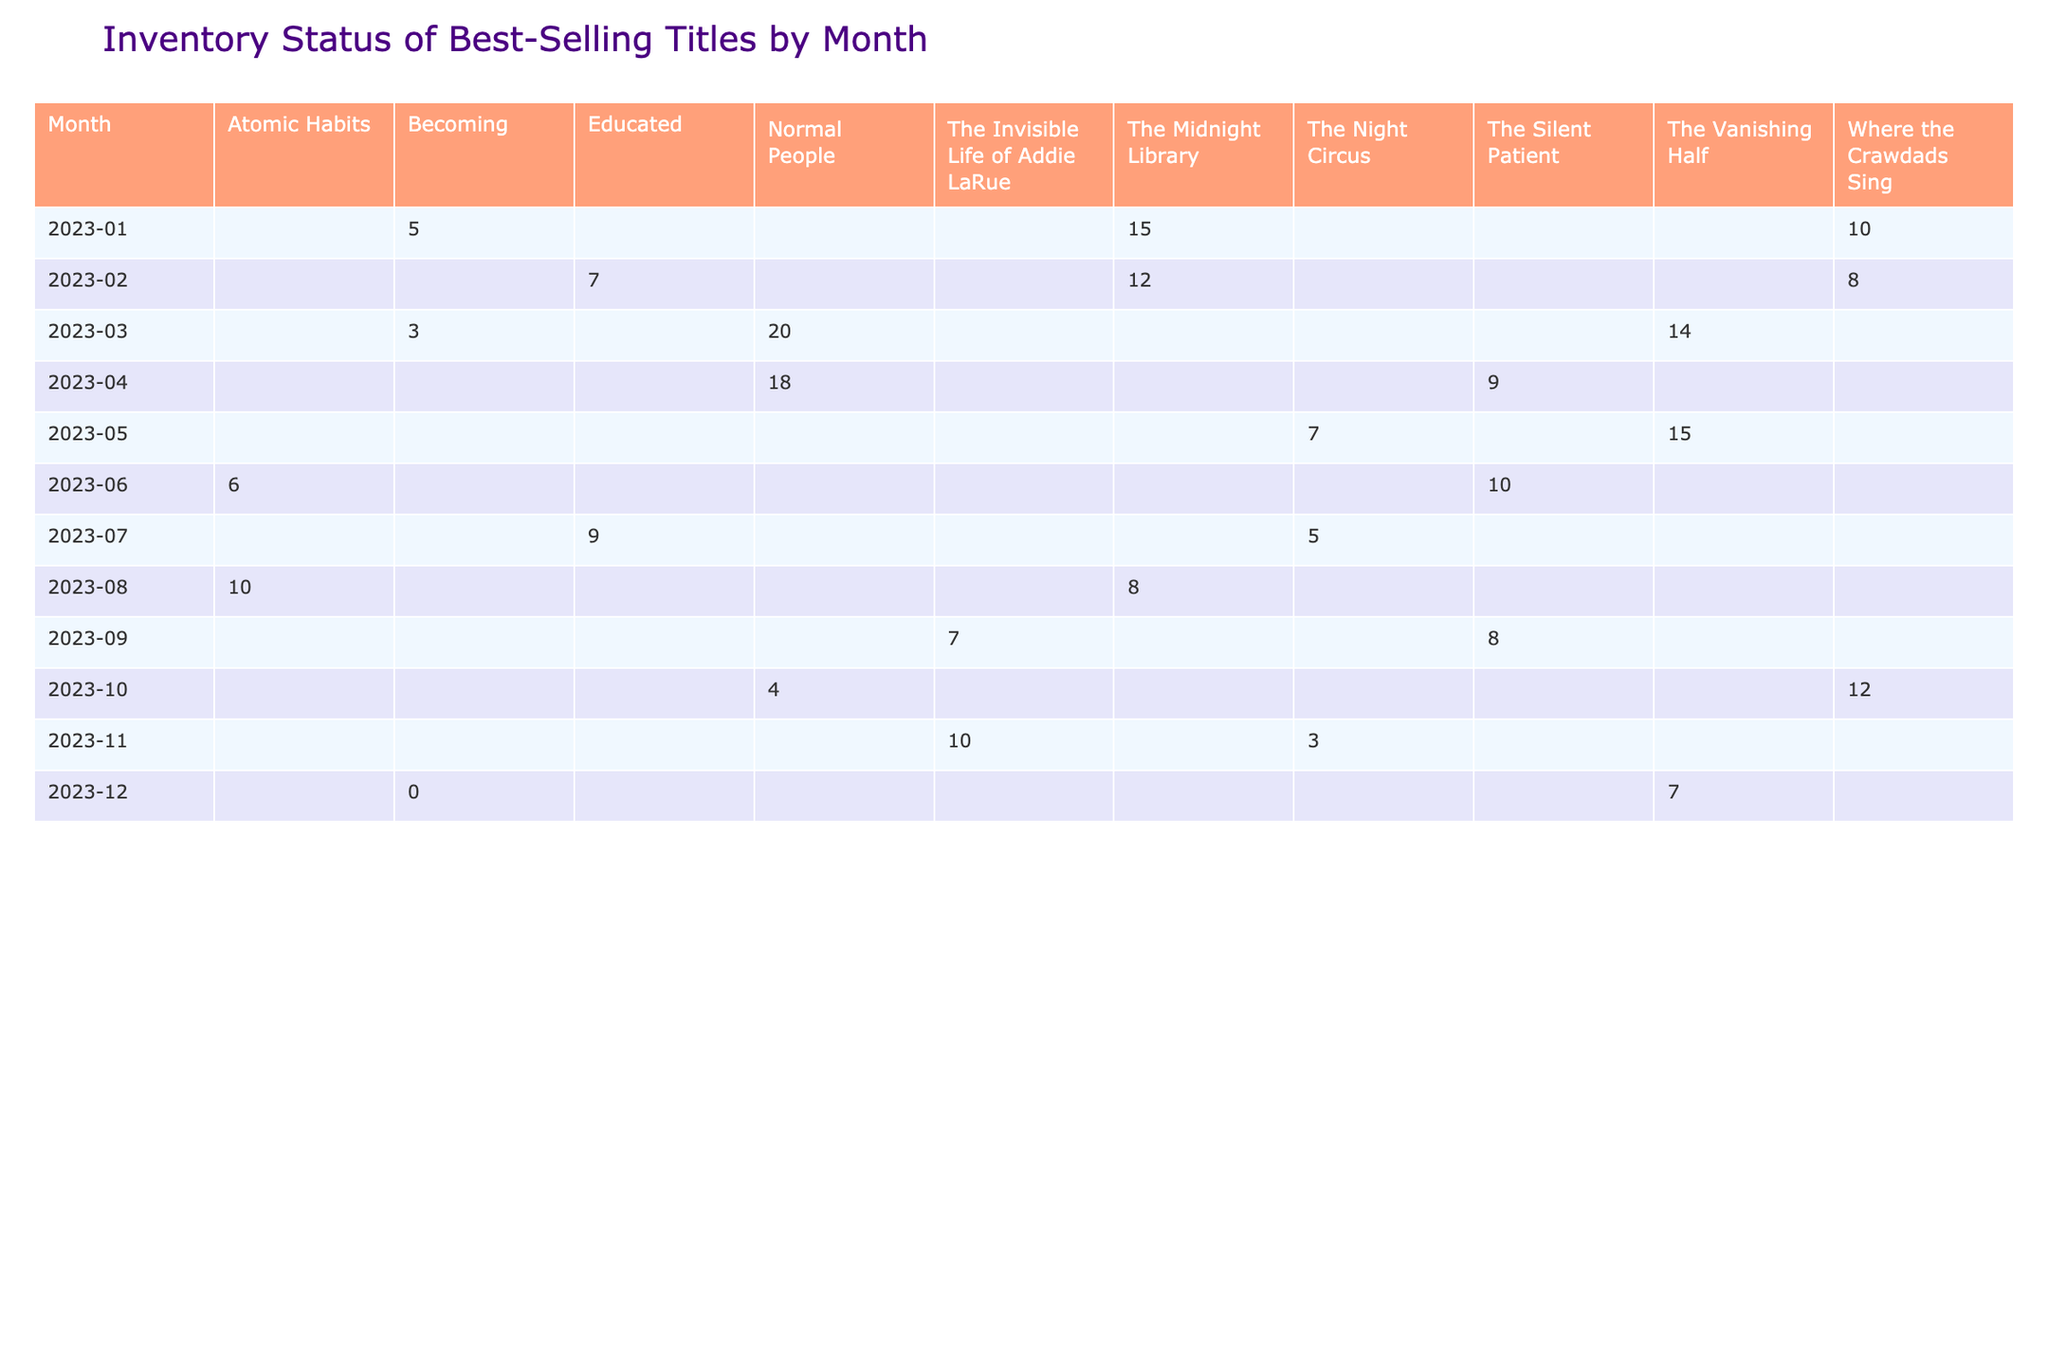What is the stock level of "The Midnight Library" in January 2023? In the January 2023 row of the table, the stock level for "The Midnight Library" is shown in that column. Looking at the value, it's 15.
Answer: 15 How many copies of "Educated" were in stock in February 2023? By checking the February 2023 row, the stock level for "Educated" is visible in its corresponding column. The value is 7.
Answer: 7 Which title had 0 stock in December 2023? Looking at the December 2023 row, the stock levels are displayed. "Becoming" shows a stock level of 0, indicating no copies were available.
Answer: Becoming What was the stock level of "Normal People" in March 2023 compared to April 2023? In March 2023, the stock level of "Normal People" is 20, and in April, it decreased to 18. This indicates a drop in stock.
Answer: It decreased from 20 to 18 What is the total stock level for "The Night Circus" over the months it appears in the table? The title "The Night Circus" appears in May (7), July (5), and November (3). Adding these values together gives 7 + 5 + 3 = 15.
Answer: 15 Which author had the most stock level of their book in April 2023? Checking the April 2023 row, the titles and their corresponding stock levels show "Normal People" by Sally Rooney has the highest with 18.
Answer: Sally Rooney Did "Becoming" have a higher stock level in any other month compared to December 2023? Looking at the table, "Becoming" had stock levels of 5 in January, 3 in March, and 7 in February, all higher than 0 in December.
Answer: Yes What is the average stock level for the book "The Silent Patient"? The stock levels for "The Silent Patient" are 9 in April, 10 in June, and 8 in September. Summing these gives 9 + 10 + 8 = 27. There are 3 entries, so the average is 27 / 3 = 9.
Answer: 9 In which month did "Where the Crawdads Sing" have its highest stock level? "Where the Crawdads Sing" shows stock levels of 10 in January, 8 in February, 12 in October, and only 4 in the subsequent months. The highest value is 12 in October.
Answer: October How many titles had stock levels below 5 in July 2023? In July, the stock levels are 5 for "The Night Circus" and 9 for "Educated". No titles have a stock level below 5 during this month.
Answer: 0 